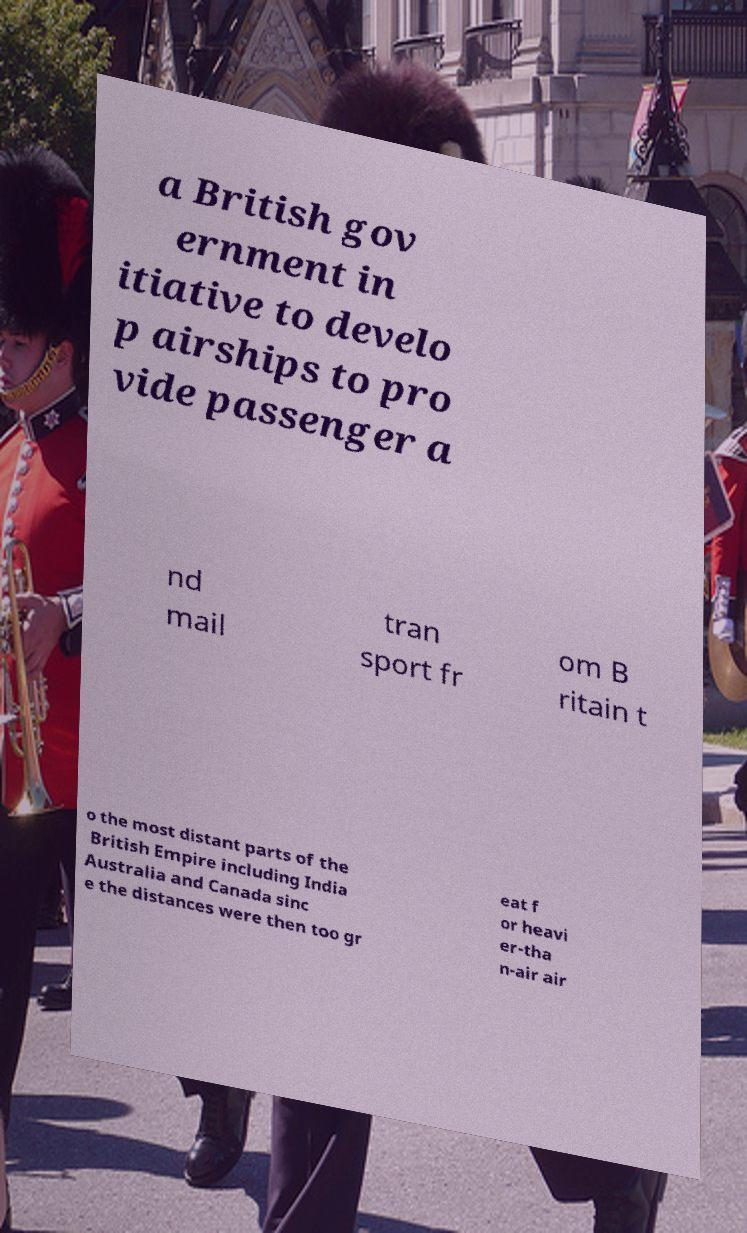Can you read and provide the text displayed in the image?This photo seems to have some interesting text. Can you extract and type it out for me? a British gov ernment in itiative to develo p airships to pro vide passenger a nd mail tran sport fr om B ritain t o the most distant parts of the British Empire including India Australia and Canada sinc e the distances were then too gr eat f or heavi er-tha n-air air 